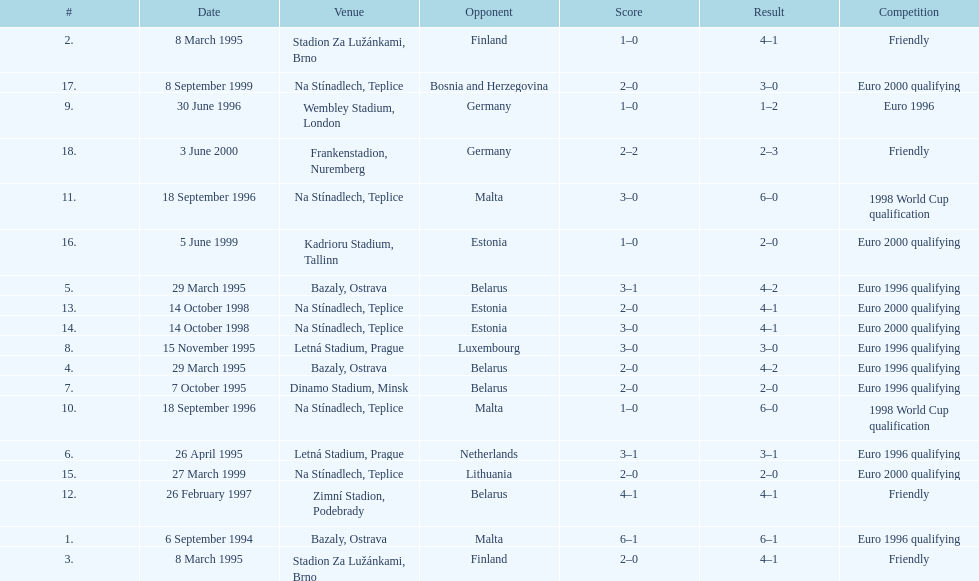What was the number of times czech republic played against germany? 2. 